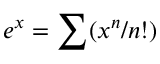<formula> <loc_0><loc_0><loc_500><loc_500>e ^ { x } = \sum ( x ^ { n } / n ! )</formula> 